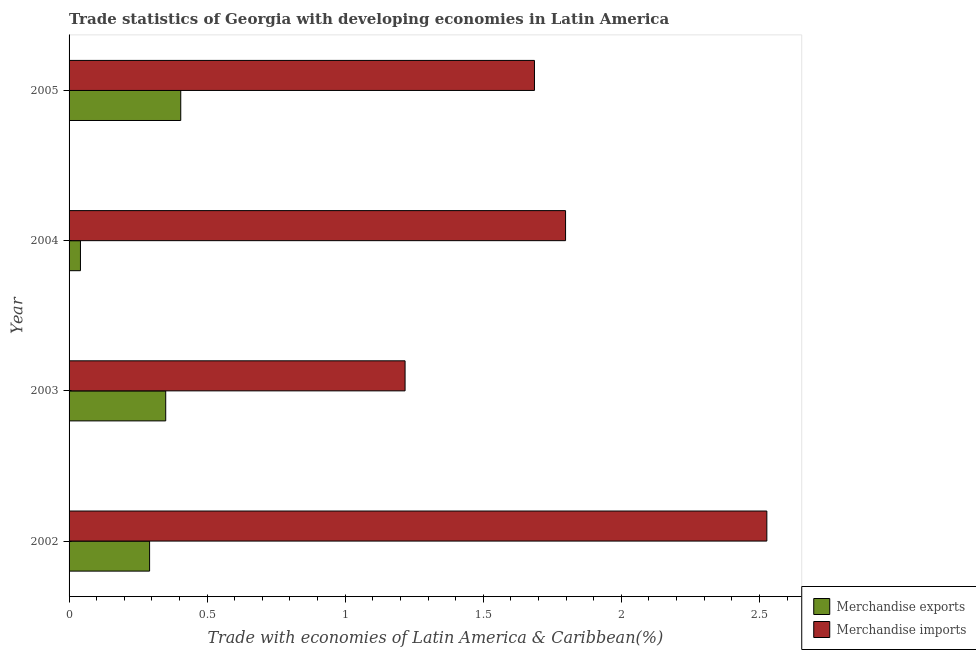How many different coloured bars are there?
Provide a short and direct response. 2. How many groups of bars are there?
Ensure brevity in your answer.  4. Are the number of bars on each tick of the Y-axis equal?
Make the answer very short. Yes. How many bars are there on the 4th tick from the top?
Your answer should be very brief. 2. How many bars are there on the 1st tick from the bottom?
Ensure brevity in your answer.  2. In how many cases, is the number of bars for a given year not equal to the number of legend labels?
Provide a short and direct response. 0. What is the merchandise exports in 2002?
Offer a terse response. 0.29. Across all years, what is the maximum merchandise imports?
Offer a very short reply. 2.53. Across all years, what is the minimum merchandise imports?
Make the answer very short. 1.22. In which year was the merchandise exports maximum?
Your answer should be very brief. 2005. In which year was the merchandise imports minimum?
Provide a short and direct response. 2003. What is the total merchandise exports in the graph?
Provide a succinct answer. 1.09. What is the difference between the merchandise imports in 2003 and that in 2005?
Keep it short and to the point. -0.47. What is the difference between the merchandise imports in 2004 and the merchandise exports in 2005?
Give a very brief answer. 1.39. What is the average merchandise exports per year?
Your response must be concise. 0.27. In the year 2002, what is the difference between the merchandise imports and merchandise exports?
Make the answer very short. 2.23. What is the ratio of the merchandise imports in 2004 to that in 2005?
Keep it short and to the point. 1.07. What is the difference between the highest and the second highest merchandise imports?
Make the answer very short. 0.73. What is the difference between the highest and the lowest merchandise exports?
Make the answer very short. 0.36. In how many years, is the merchandise imports greater than the average merchandise imports taken over all years?
Provide a succinct answer. 1. Is the sum of the merchandise imports in 2003 and 2004 greater than the maximum merchandise exports across all years?
Keep it short and to the point. Yes. What does the 1st bar from the top in 2005 represents?
Your response must be concise. Merchandise imports. What is the difference between two consecutive major ticks on the X-axis?
Provide a succinct answer. 0.5. Does the graph contain grids?
Make the answer very short. No. Where does the legend appear in the graph?
Provide a succinct answer. Bottom right. How many legend labels are there?
Your response must be concise. 2. What is the title of the graph?
Your response must be concise. Trade statistics of Georgia with developing economies in Latin America. Does "IMF nonconcessional" appear as one of the legend labels in the graph?
Offer a terse response. No. What is the label or title of the X-axis?
Offer a terse response. Trade with economies of Latin America & Caribbean(%). What is the label or title of the Y-axis?
Your answer should be compact. Year. What is the Trade with economies of Latin America & Caribbean(%) of Merchandise exports in 2002?
Offer a very short reply. 0.29. What is the Trade with economies of Latin America & Caribbean(%) of Merchandise imports in 2002?
Your response must be concise. 2.53. What is the Trade with economies of Latin America & Caribbean(%) of Merchandise exports in 2003?
Provide a short and direct response. 0.35. What is the Trade with economies of Latin America & Caribbean(%) of Merchandise imports in 2003?
Give a very brief answer. 1.22. What is the Trade with economies of Latin America & Caribbean(%) in Merchandise exports in 2004?
Your response must be concise. 0.04. What is the Trade with economies of Latin America & Caribbean(%) of Merchandise imports in 2004?
Make the answer very short. 1.8. What is the Trade with economies of Latin America & Caribbean(%) in Merchandise exports in 2005?
Give a very brief answer. 0.4. What is the Trade with economies of Latin America & Caribbean(%) in Merchandise imports in 2005?
Ensure brevity in your answer.  1.69. Across all years, what is the maximum Trade with economies of Latin America & Caribbean(%) of Merchandise exports?
Your response must be concise. 0.4. Across all years, what is the maximum Trade with economies of Latin America & Caribbean(%) of Merchandise imports?
Provide a short and direct response. 2.53. Across all years, what is the minimum Trade with economies of Latin America & Caribbean(%) of Merchandise exports?
Provide a short and direct response. 0.04. Across all years, what is the minimum Trade with economies of Latin America & Caribbean(%) in Merchandise imports?
Keep it short and to the point. 1.22. What is the total Trade with economies of Latin America & Caribbean(%) in Merchandise exports in the graph?
Give a very brief answer. 1.09. What is the total Trade with economies of Latin America & Caribbean(%) in Merchandise imports in the graph?
Give a very brief answer. 7.23. What is the difference between the Trade with economies of Latin America & Caribbean(%) in Merchandise exports in 2002 and that in 2003?
Provide a short and direct response. -0.06. What is the difference between the Trade with economies of Latin America & Caribbean(%) in Merchandise imports in 2002 and that in 2003?
Offer a very short reply. 1.31. What is the difference between the Trade with economies of Latin America & Caribbean(%) of Merchandise exports in 2002 and that in 2004?
Your response must be concise. 0.25. What is the difference between the Trade with economies of Latin America & Caribbean(%) of Merchandise imports in 2002 and that in 2004?
Provide a short and direct response. 0.73. What is the difference between the Trade with economies of Latin America & Caribbean(%) of Merchandise exports in 2002 and that in 2005?
Ensure brevity in your answer.  -0.11. What is the difference between the Trade with economies of Latin America & Caribbean(%) in Merchandise imports in 2002 and that in 2005?
Your response must be concise. 0.84. What is the difference between the Trade with economies of Latin America & Caribbean(%) of Merchandise exports in 2003 and that in 2004?
Offer a very short reply. 0.31. What is the difference between the Trade with economies of Latin America & Caribbean(%) of Merchandise imports in 2003 and that in 2004?
Offer a very short reply. -0.58. What is the difference between the Trade with economies of Latin America & Caribbean(%) in Merchandise exports in 2003 and that in 2005?
Provide a short and direct response. -0.05. What is the difference between the Trade with economies of Latin America & Caribbean(%) of Merchandise imports in 2003 and that in 2005?
Provide a short and direct response. -0.47. What is the difference between the Trade with economies of Latin America & Caribbean(%) of Merchandise exports in 2004 and that in 2005?
Offer a very short reply. -0.36. What is the difference between the Trade with economies of Latin America & Caribbean(%) in Merchandise imports in 2004 and that in 2005?
Give a very brief answer. 0.11. What is the difference between the Trade with economies of Latin America & Caribbean(%) in Merchandise exports in 2002 and the Trade with economies of Latin America & Caribbean(%) in Merchandise imports in 2003?
Ensure brevity in your answer.  -0.93. What is the difference between the Trade with economies of Latin America & Caribbean(%) of Merchandise exports in 2002 and the Trade with economies of Latin America & Caribbean(%) of Merchandise imports in 2004?
Offer a very short reply. -1.51. What is the difference between the Trade with economies of Latin America & Caribbean(%) in Merchandise exports in 2002 and the Trade with economies of Latin America & Caribbean(%) in Merchandise imports in 2005?
Offer a very short reply. -1.39. What is the difference between the Trade with economies of Latin America & Caribbean(%) in Merchandise exports in 2003 and the Trade with economies of Latin America & Caribbean(%) in Merchandise imports in 2004?
Provide a succinct answer. -1.45. What is the difference between the Trade with economies of Latin America & Caribbean(%) in Merchandise exports in 2003 and the Trade with economies of Latin America & Caribbean(%) in Merchandise imports in 2005?
Keep it short and to the point. -1.34. What is the difference between the Trade with economies of Latin America & Caribbean(%) in Merchandise exports in 2004 and the Trade with economies of Latin America & Caribbean(%) in Merchandise imports in 2005?
Provide a short and direct response. -1.64. What is the average Trade with economies of Latin America & Caribbean(%) in Merchandise exports per year?
Offer a very short reply. 0.27. What is the average Trade with economies of Latin America & Caribbean(%) in Merchandise imports per year?
Make the answer very short. 1.81. In the year 2002, what is the difference between the Trade with economies of Latin America & Caribbean(%) in Merchandise exports and Trade with economies of Latin America & Caribbean(%) in Merchandise imports?
Provide a succinct answer. -2.24. In the year 2003, what is the difference between the Trade with economies of Latin America & Caribbean(%) of Merchandise exports and Trade with economies of Latin America & Caribbean(%) of Merchandise imports?
Offer a very short reply. -0.87. In the year 2004, what is the difference between the Trade with economies of Latin America & Caribbean(%) in Merchandise exports and Trade with economies of Latin America & Caribbean(%) in Merchandise imports?
Give a very brief answer. -1.76. In the year 2005, what is the difference between the Trade with economies of Latin America & Caribbean(%) of Merchandise exports and Trade with economies of Latin America & Caribbean(%) of Merchandise imports?
Provide a short and direct response. -1.28. What is the ratio of the Trade with economies of Latin America & Caribbean(%) of Merchandise exports in 2002 to that in 2003?
Make the answer very short. 0.83. What is the ratio of the Trade with economies of Latin America & Caribbean(%) of Merchandise imports in 2002 to that in 2003?
Your response must be concise. 2.08. What is the ratio of the Trade with economies of Latin America & Caribbean(%) in Merchandise exports in 2002 to that in 2004?
Offer a terse response. 7.07. What is the ratio of the Trade with economies of Latin America & Caribbean(%) in Merchandise imports in 2002 to that in 2004?
Offer a terse response. 1.41. What is the ratio of the Trade with economies of Latin America & Caribbean(%) in Merchandise exports in 2002 to that in 2005?
Offer a very short reply. 0.72. What is the ratio of the Trade with economies of Latin America & Caribbean(%) in Merchandise imports in 2002 to that in 2005?
Make the answer very short. 1.5. What is the ratio of the Trade with economies of Latin America & Caribbean(%) in Merchandise exports in 2003 to that in 2004?
Your answer should be compact. 8.49. What is the ratio of the Trade with economies of Latin America & Caribbean(%) in Merchandise imports in 2003 to that in 2004?
Provide a succinct answer. 0.68. What is the ratio of the Trade with economies of Latin America & Caribbean(%) in Merchandise exports in 2003 to that in 2005?
Make the answer very short. 0.87. What is the ratio of the Trade with economies of Latin America & Caribbean(%) in Merchandise imports in 2003 to that in 2005?
Provide a short and direct response. 0.72. What is the ratio of the Trade with economies of Latin America & Caribbean(%) of Merchandise exports in 2004 to that in 2005?
Give a very brief answer. 0.1. What is the ratio of the Trade with economies of Latin America & Caribbean(%) in Merchandise imports in 2004 to that in 2005?
Give a very brief answer. 1.07. What is the difference between the highest and the second highest Trade with economies of Latin America & Caribbean(%) of Merchandise exports?
Give a very brief answer. 0.05. What is the difference between the highest and the second highest Trade with economies of Latin America & Caribbean(%) in Merchandise imports?
Ensure brevity in your answer.  0.73. What is the difference between the highest and the lowest Trade with economies of Latin America & Caribbean(%) in Merchandise exports?
Give a very brief answer. 0.36. What is the difference between the highest and the lowest Trade with economies of Latin America & Caribbean(%) in Merchandise imports?
Provide a short and direct response. 1.31. 